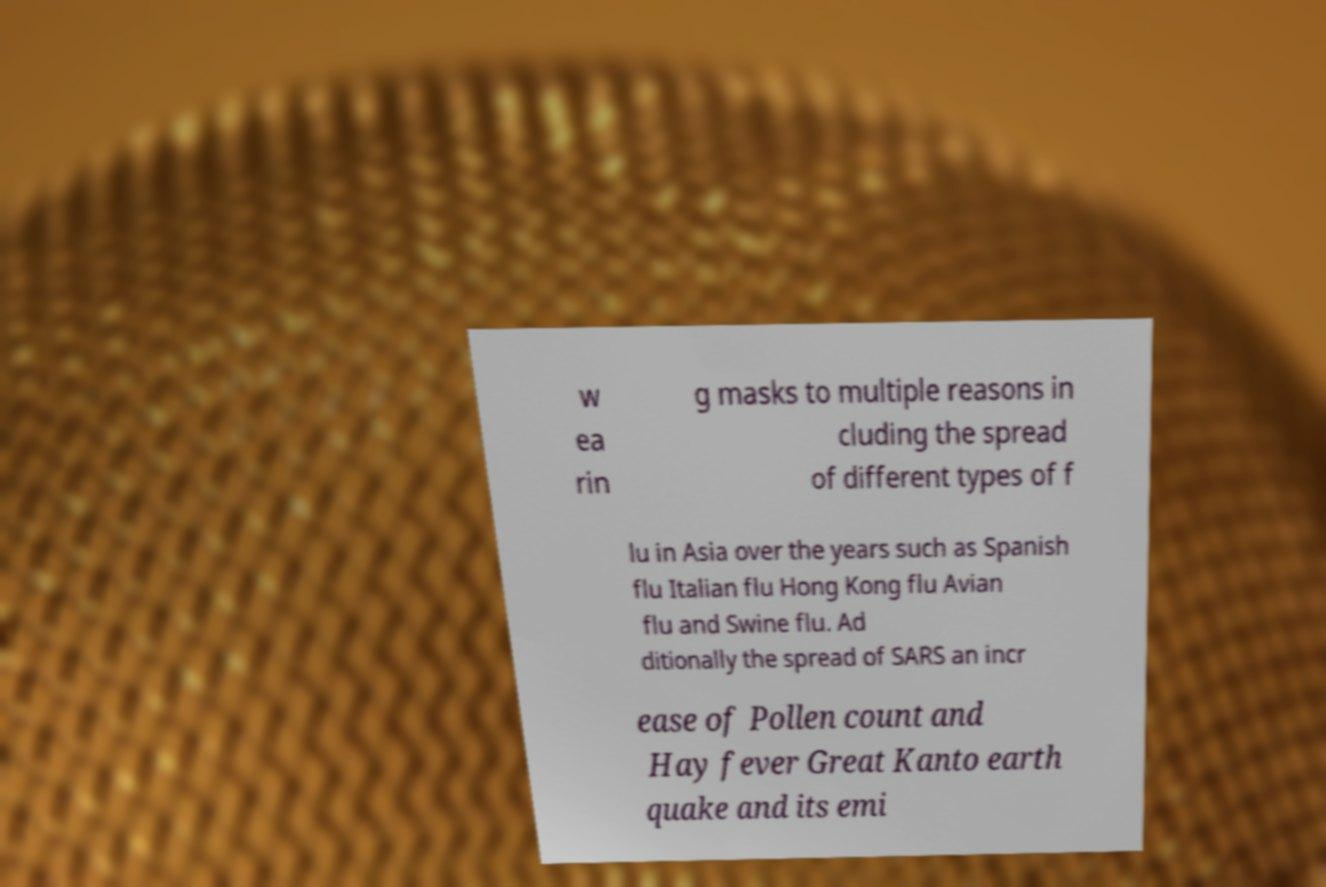Please identify and transcribe the text found in this image. w ea rin g masks to multiple reasons in cluding the spread of different types of f lu in Asia over the years such as Spanish flu Italian flu Hong Kong flu Avian flu and Swine flu. Ad ditionally the spread of SARS an incr ease of Pollen count and Hay fever Great Kanto earth quake and its emi 